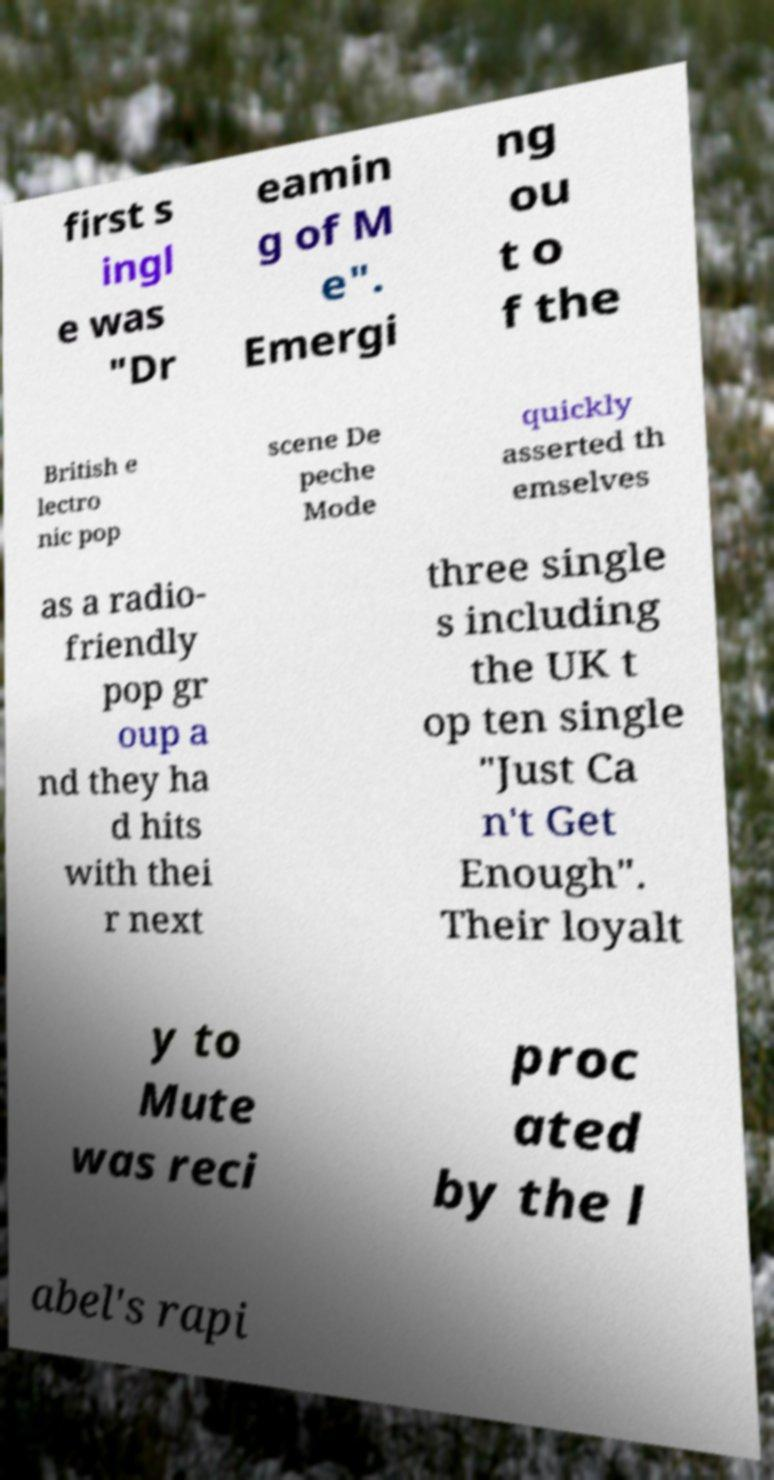Can you accurately transcribe the text from the provided image for me? first s ingl e was "Dr eamin g of M e". Emergi ng ou t o f the British e lectro nic pop scene De peche Mode quickly asserted th emselves as a radio- friendly pop gr oup a nd they ha d hits with thei r next three single s including the UK t op ten single "Just Ca n't Get Enough". Their loyalt y to Mute was reci proc ated by the l abel's rapi 